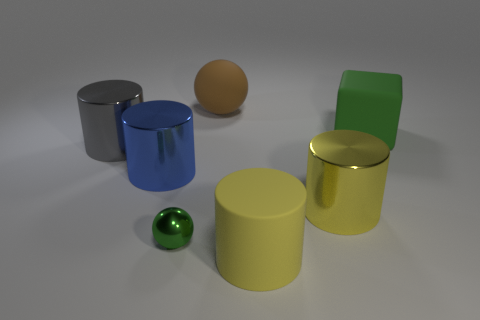Subtract all metal cylinders. How many cylinders are left? 1 Add 2 large brown spheres. How many objects exist? 9 Subtract all cyan balls. How many red cubes are left? 0 Subtract all gray things. Subtract all big yellow objects. How many objects are left? 4 Add 4 gray things. How many gray things are left? 5 Add 3 big cyan cylinders. How many big cyan cylinders exist? 3 Subtract all brown balls. How many balls are left? 1 Subtract 0 cyan balls. How many objects are left? 7 Subtract all blocks. How many objects are left? 6 Subtract 1 spheres. How many spheres are left? 1 